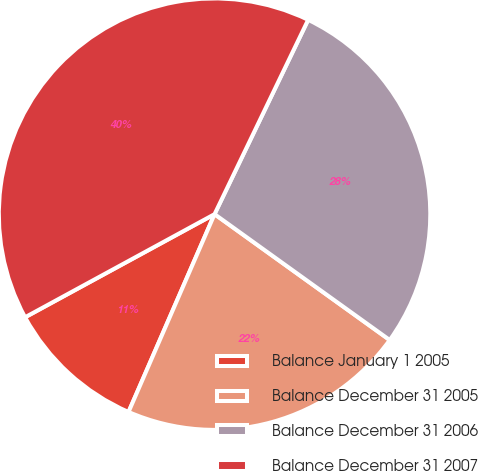<chart> <loc_0><loc_0><loc_500><loc_500><pie_chart><fcel>Balance January 1 2005<fcel>Balance December 31 2005<fcel>Balance December 31 2006<fcel>Balance December 31 2007<nl><fcel>10.54%<fcel>21.61%<fcel>27.77%<fcel>40.07%<nl></chart> 